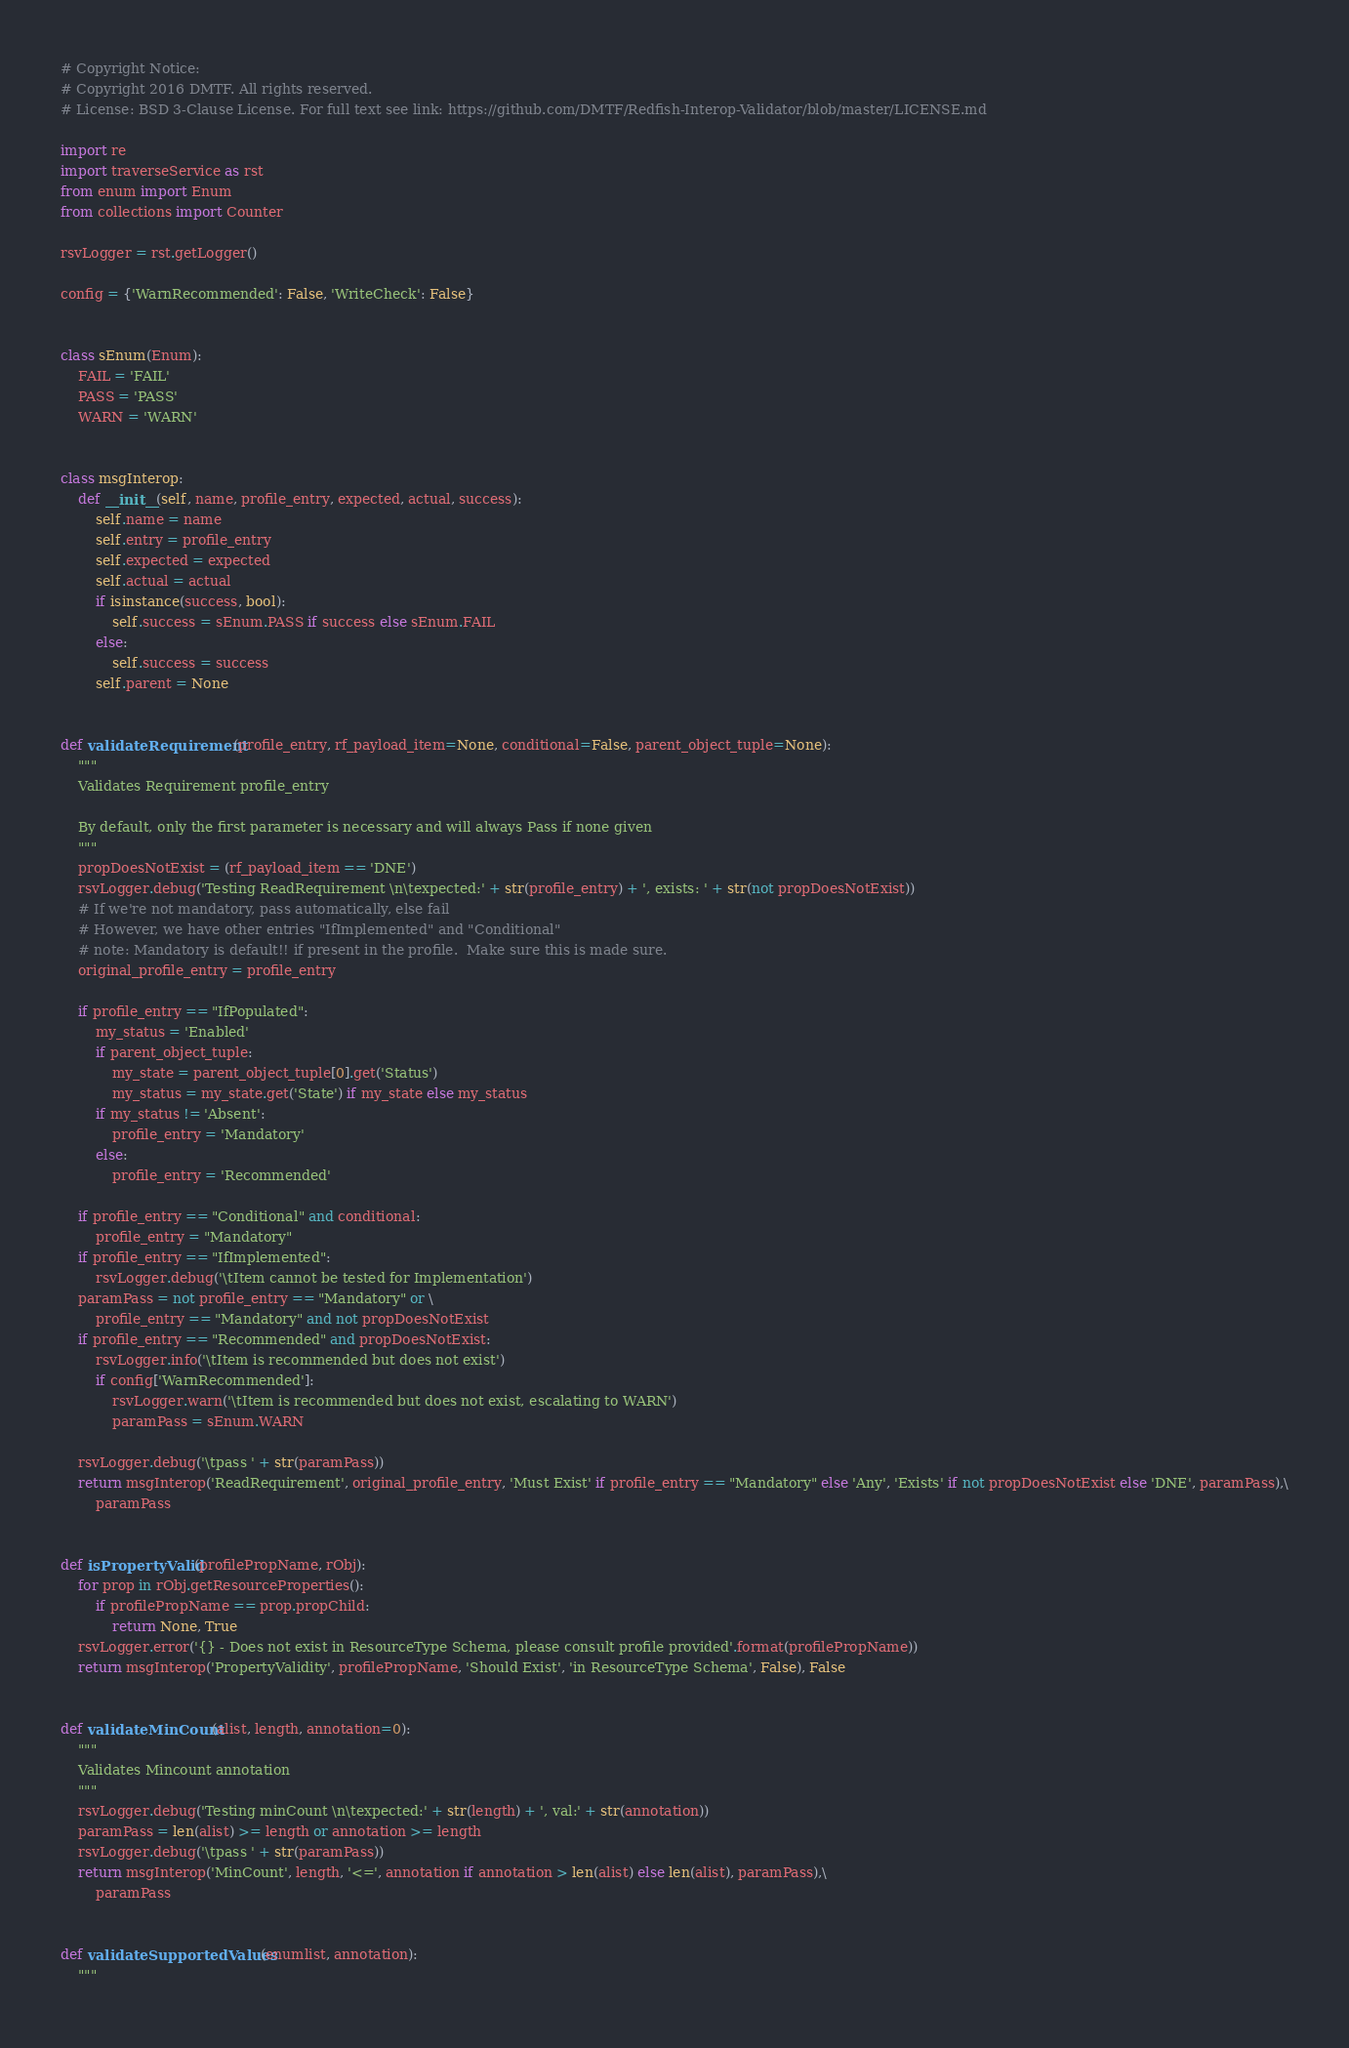Convert code to text. <code><loc_0><loc_0><loc_500><loc_500><_Python_>
# Copyright Notice:
# Copyright 2016 DMTF. All rights reserved.
# License: BSD 3-Clause License. For full text see link: https://github.com/DMTF/Redfish-Interop-Validator/blob/master/LICENSE.md

import re
import traverseService as rst
from enum import Enum
from collections import Counter

rsvLogger = rst.getLogger()

config = {'WarnRecommended': False, 'WriteCheck': False}


class sEnum(Enum):
    FAIL = 'FAIL'
    PASS = 'PASS'
    WARN = 'WARN'


class msgInterop:
    def __init__(self, name, profile_entry, expected, actual, success):
        self.name = name
        self.entry = profile_entry
        self.expected = expected
        self.actual = actual
        if isinstance(success, bool):
            self.success = sEnum.PASS if success else sEnum.FAIL
        else:
            self.success = success
        self.parent = None


def validateRequirement(profile_entry, rf_payload_item=None, conditional=False, parent_object_tuple=None):
    """
    Validates Requirement profile_entry

    By default, only the first parameter is necessary and will always Pass if none given
    """
    propDoesNotExist = (rf_payload_item == 'DNE')
    rsvLogger.debug('Testing ReadRequirement \n\texpected:' + str(profile_entry) + ', exists: ' + str(not propDoesNotExist))
    # If we're not mandatory, pass automatically, else fail
    # However, we have other entries "IfImplemented" and "Conditional"
    # note: Mandatory is default!! if present in the profile.  Make sure this is made sure.
    original_profile_entry = profile_entry

    if profile_entry == "IfPopulated":
        my_status = 'Enabled'
        if parent_object_tuple:
            my_state = parent_object_tuple[0].get('Status')
            my_status = my_state.get('State') if my_state else my_status
        if my_status != 'Absent':
            profile_entry = 'Mandatory'
        else:
            profile_entry = 'Recommended'

    if profile_entry == "Conditional" and conditional:
        profile_entry = "Mandatory"
    if profile_entry == "IfImplemented":
        rsvLogger.debug('\tItem cannot be tested for Implementation')
    paramPass = not profile_entry == "Mandatory" or \
        profile_entry == "Mandatory" and not propDoesNotExist
    if profile_entry == "Recommended" and propDoesNotExist:
        rsvLogger.info('\tItem is recommended but does not exist')
        if config['WarnRecommended']:
            rsvLogger.warn('\tItem is recommended but does not exist, escalating to WARN')
            paramPass = sEnum.WARN

    rsvLogger.debug('\tpass ' + str(paramPass))
    return msgInterop('ReadRequirement', original_profile_entry, 'Must Exist' if profile_entry == "Mandatory" else 'Any', 'Exists' if not propDoesNotExist else 'DNE', paramPass),\
        paramPass


def isPropertyValid(profilePropName, rObj):
    for prop in rObj.getResourceProperties():
        if profilePropName == prop.propChild:
            return None, True
    rsvLogger.error('{} - Does not exist in ResourceType Schema, please consult profile provided'.format(profilePropName))
    return msgInterop('PropertyValidity', profilePropName, 'Should Exist', 'in ResourceType Schema', False), False


def validateMinCount(alist, length, annotation=0):
    """
    Validates Mincount annotation
    """
    rsvLogger.debug('Testing minCount \n\texpected:' + str(length) + ', val:' + str(annotation))
    paramPass = len(alist) >= length or annotation >= length
    rsvLogger.debug('\tpass ' + str(paramPass))
    return msgInterop('MinCount', length, '<=', annotation if annotation > len(alist) else len(alist), paramPass),\
        paramPass


def validateSupportedValues(enumlist, annotation):
    """</code> 